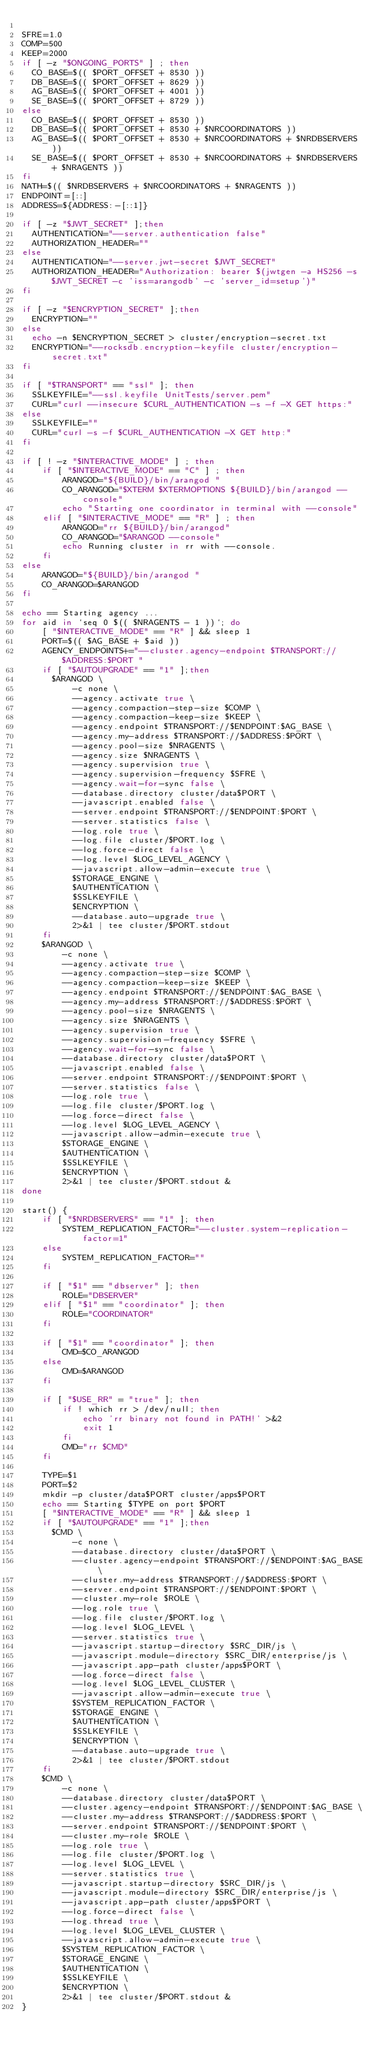<code> <loc_0><loc_0><loc_500><loc_500><_Bash_>
SFRE=1.0
COMP=500
KEEP=2000
if [ -z "$ONGOING_PORTS" ] ; then
  CO_BASE=$(( $PORT_OFFSET + 8530 ))
  DB_BASE=$(( $PORT_OFFSET + 8629 ))
  AG_BASE=$(( $PORT_OFFSET + 4001 ))
  SE_BASE=$(( $PORT_OFFSET + 8729 ))
else
  CO_BASE=$(( $PORT_OFFSET + 8530 ))
  DB_BASE=$(( $PORT_OFFSET + 8530 + $NRCOORDINATORS ))
  AG_BASE=$(( $PORT_OFFSET + 8530 + $NRCOORDINATORS + $NRDBSERVERS ))
  SE_BASE=$(( $PORT_OFFSET + 8530 + $NRCOORDINATORS + $NRDBSERVERS + $NRAGENTS ))
fi
NATH=$(( $NRDBSERVERS + $NRCOORDINATORS + $NRAGENTS ))
ENDPOINT=[::]
ADDRESS=${ADDRESS:-[::1]}

if [ -z "$JWT_SECRET" ];then
  AUTHENTICATION="--server.authentication false"
  AUTHORIZATION_HEADER=""
else
  AUTHENTICATION="--server.jwt-secret $JWT_SECRET"
  AUTHORIZATION_HEADER="Authorization: bearer $(jwtgen -a HS256 -s $JWT_SECRET -c 'iss=arangodb' -c 'server_id=setup')"
fi

if [ -z "$ENCRYPTION_SECRET" ];then
  ENCRYPTION=""
else
  echo -n $ENCRYPTION_SECRET > cluster/encryption-secret.txt
  ENCRYPTION="--rocksdb.encryption-keyfile cluster/encryption-secret.txt"
fi

if [ "$TRANSPORT" == "ssl" ]; then
  SSLKEYFILE="--ssl.keyfile UnitTests/server.pem"
  CURL="curl --insecure $CURL_AUTHENTICATION -s -f -X GET https:"
else
  SSLKEYFILE=""
  CURL="curl -s -f $CURL_AUTHENTICATION -X GET http:"
fi

if [ ! -z "$INTERACTIVE_MODE" ] ; then
    if [ "$INTERACTIVE_MODE" == "C" ] ; then
        ARANGOD="${BUILD}/bin/arangod "
        CO_ARANGOD="$XTERM $XTERMOPTIONS ${BUILD}/bin/arangod --console"
        echo "Starting one coordinator in terminal with --console"
    elif [ "$INTERACTIVE_MODE" == "R" ] ; then
        ARANGOD="rr ${BUILD}/bin/arangod"
        CO_ARANGOD="$ARANGOD --console"
        echo Running cluster in rr with --console.
    fi
else
    ARANGOD="${BUILD}/bin/arangod "
    CO_ARANGOD=$ARANGOD
fi

echo == Starting agency ...
for aid in `seq 0 $(( $NRAGENTS - 1 ))`; do
    [ "$INTERACTIVE_MODE" == "R" ] && sleep 1
    PORT=$(( $AG_BASE + $aid ))
    AGENCY_ENDPOINTS+="--cluster.agency-endpoint $TRANSPORT://$ADDRESS:$PORT "
    if [ "$AUTOUPGRADE" == "1" ];then
      $ARANGOD \
          -c none \
          --agency.activate true \
          --agency.compaction-step-size $COMP \
          --agency.compaction-keep-size $KEEP \
          --agency.endpoint $TRANSPORT://$ENDPOINT:$AG_BASE \
          --agency.my-address $TRANSPORT://$ADDRESS:$PORT \
          --agency.pool-size $NRAGENTS \
          --agency.size $NRAGENTS \
          --agency.supervision true \
          --agency.supervision-frequency $SFRE \
          --agency.wait-for-sync false \
          --database.directory cluster/data$PORT \
          --javascript.enabled false \
          --server.endpoint $TRANSPORT://$ENDPOINT:$PORT \
          --server.statistics false \
          --log.role true \
          --log.file cluster/$PORT.log \
          --log.force-direct false \
          --log.level $LOG_LEVEL_AGENCY \
          --javascript.allow-admin-execute true \
          $STORAGE_ENGINE \
          $AUTHENTICATION \
          $SSLKEYFILE \
          $ENCRYPTION \
          --database.auto-upgrade true \
          2>&1 | tee cluster/$PORT.stdout
    fi
    $ARANGOD \
        -c none \
        --agency.activate true \
        --agency.compaction-step-size $COMP \
        --agency.compaction-keep-size $KEEP \
        --agency.endpoint $TRANSPORT://$ENDPOINT:$AG_BASE \
        --agency.my-address $TRANSPORT://$ADDRESS:$PORT \
        --agency.pool-size $NRAGENTS \
        --agency.size $NRAGENTS \
        --agency.supervision true \
        --agency.supervision-frequency $SFRE \
        --agency.wait-for-sync false \
        --database.directory cluster/data$PORT \
        --javascript.enabled false \
        --server.endpoint $TRANSPORT://$ENDPOINT:$PORT \
        --server.statistics false \
        --log.role true \
        --log.file cluster/$PORT.log \
        --log.force-direct false \
        --log.level $LOG_LEVEL_AGENCY \
        --javascript.allow-admin-execute true \
        $STORAGE_ENGINE \
        $AUTHENTICATION \
        $SSLKEYFILE \
        $ENCRYPTION \
        2>&1 | tee cluster/$PORT.stdout &
done

start() {
    if [ "$NRDBSERVERS" == "1" ]; then
        SYSTEM_REPLICATION_FACTOR="--cluster.system-replication-factor=1"
    else
        SYSTEM_REPLICATION_FACTOR=""
    fi

    if [ "$1" == "dbserver" ]; then
        ROLE="DBSERVER"
    elif [ "$1" == "coordinator" ]; then
        ROLE="COORDINATOR"
    fi

    if [ "$1" == "coordinator" ]; then
        CMD=$CO_ARANGOD
    else
        CMD=$ARANGOD
    fi

    if [ "$USE_RR" = "true" ]; then
        if ! which rr > /dev/null; then
            echo 'rr binary not found in PATH!' >&2
            exit 1
        fi
        CMD="rr $CMD"
    fi

    TYPE=$1
    PORT=$2
    mkdir -p cluster/data$PORT cluster/apps$PORT
    echo == Starting $TYPE on port $PORT
    [ "$INTERACTIVE_MODE" == "R" ] && sleep 1
    if [ "$AUTOUPGRADE" == "1" ];then
      $CMD \
          -c none \
          --database.directory cluster/data$PORT \
          --cluster.agency-endpoint $TRANSPORT://$ENDPOINT:$AG_BASE \
          --cluster.my-address $TRANSPORT://$ADDRESS:$PORT \
          --server.endpoint $TRANSPORT://$ENDPOINT:$PORT \
          --cluster.my-role $ROLE \
          --log.role true \
          --log.file cluster/$PORT.log \
          --log.level $LOG_LEVEL \
          --server.statistics true \
          --javascript.startup-directory $SRC_DIR/js \
          --javascript.module-directory $SRC_DIR/enterprise/js \
          --javascript.app-path cluster/apps$PORT \
          --log.force-direct false \
          --log.level $LOG_LEVEL_CLUSTER \
          --javascript.allow-admin-execute true \
          $SYSTEM_REPLICATION_FACTOR \
          $STORAGE_ENGINE \
          $AUTHENTICATION \
          $SSLKEYFILE \
          $ENCRYPTION \
          --database.auto-upgrade true \
          2>&1 | tee cluster/$PORT.stdout
    fi
    $CMD \
        -c none \
        --database.directory cluster/data$PORT \
        --cluster.agency-endpoint $TRANSPORT://$ENDPOINT:$AG_BASE \
        --cluster.my-address $TRANSPORT://$ADDRESS:$PORT \
        --server.endpoint $TRANSPORT://$ENDPOINT:$PORT \
        --cluster.my-role $ROLE \
        --log.role true \
        --log.file cluster/$PORT.log \
        --log.level $LOG_LEVEL \
        --server.statistics true \
        --javascript.startup-directory $SRC_DIR/js \
        --javascript.module-directory $SRC_DIR/enterprise/js \
        --javascript.app-path cluster/apps$PORT \
        --log.force-direct false \
        --log.thread true \
        --log.level $LOG_LEVEL_CLUSTER \
        --javascript.allow-admin-execute true \
        $SYSTEM_REPLICATION_FACTOR \
        $STORAGE_ENGINE \
        $AUTHENTICATION \
        $SSLKEYFILE \
        $ENCRYPTION \
        2>&1 | tee cluster/$PORT.stdout &
}
</code> 